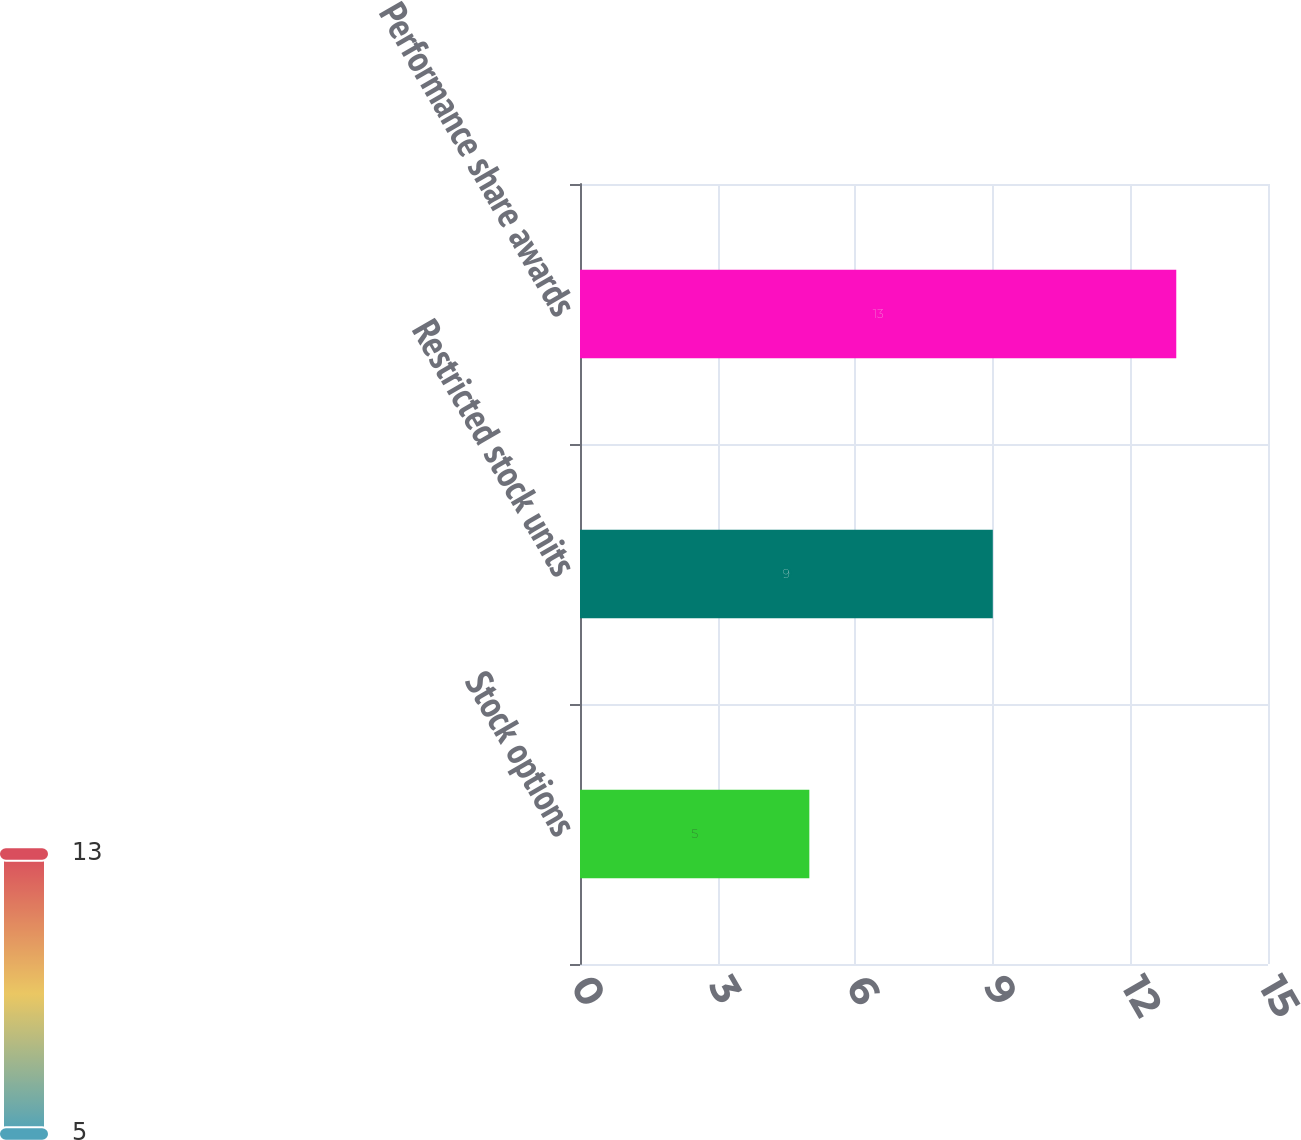Convert chart. <chart><loc_0><loc_0><loc_500><loc_500><bar_chart><fcel>Stock options<fcel>Restricted stock units<fcel>Performance share awards<nl><fcel>5<fcel>9<fcel>13<nl></chart> 